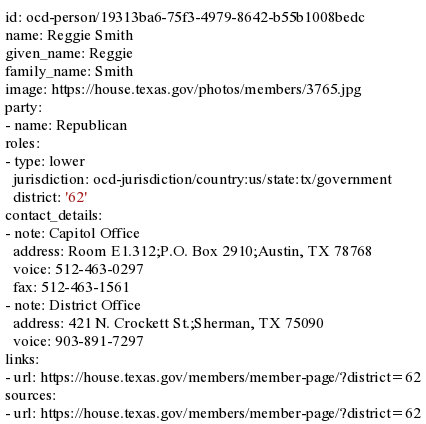<code> <loc_0><loc_0><loc_500><loc_500><_YAML_>id: ocd-person/19313ba6-75f3-4979-8642-b55b1008bedc
name: Reggie Smith
given_name: Reggie
family_name: Smith
image: https://house.texas.gov/photos/members/3765.jpg
party:
- name: Republican
roles:
- type: lower
  jurisdiction: ocd-jurisdiction/country:us/state:tx/government
  district: '62'
contact_details:
- note: Capitol Office
  address: Room E1.312;P.O. Box 2910;Austin, TX 78768
  voice: 512-463-0297
  fax: 512-463-1561
- note: District Office
  address: 421 N. Crockett St.;Sherman, TX 75090
  voice: 903-891-7297
links:
- url: https://house.texas.gov/members/member-page/?district=62
sources:
- url: https://house.texas.gov/members/member-page/?district=62
</code> 